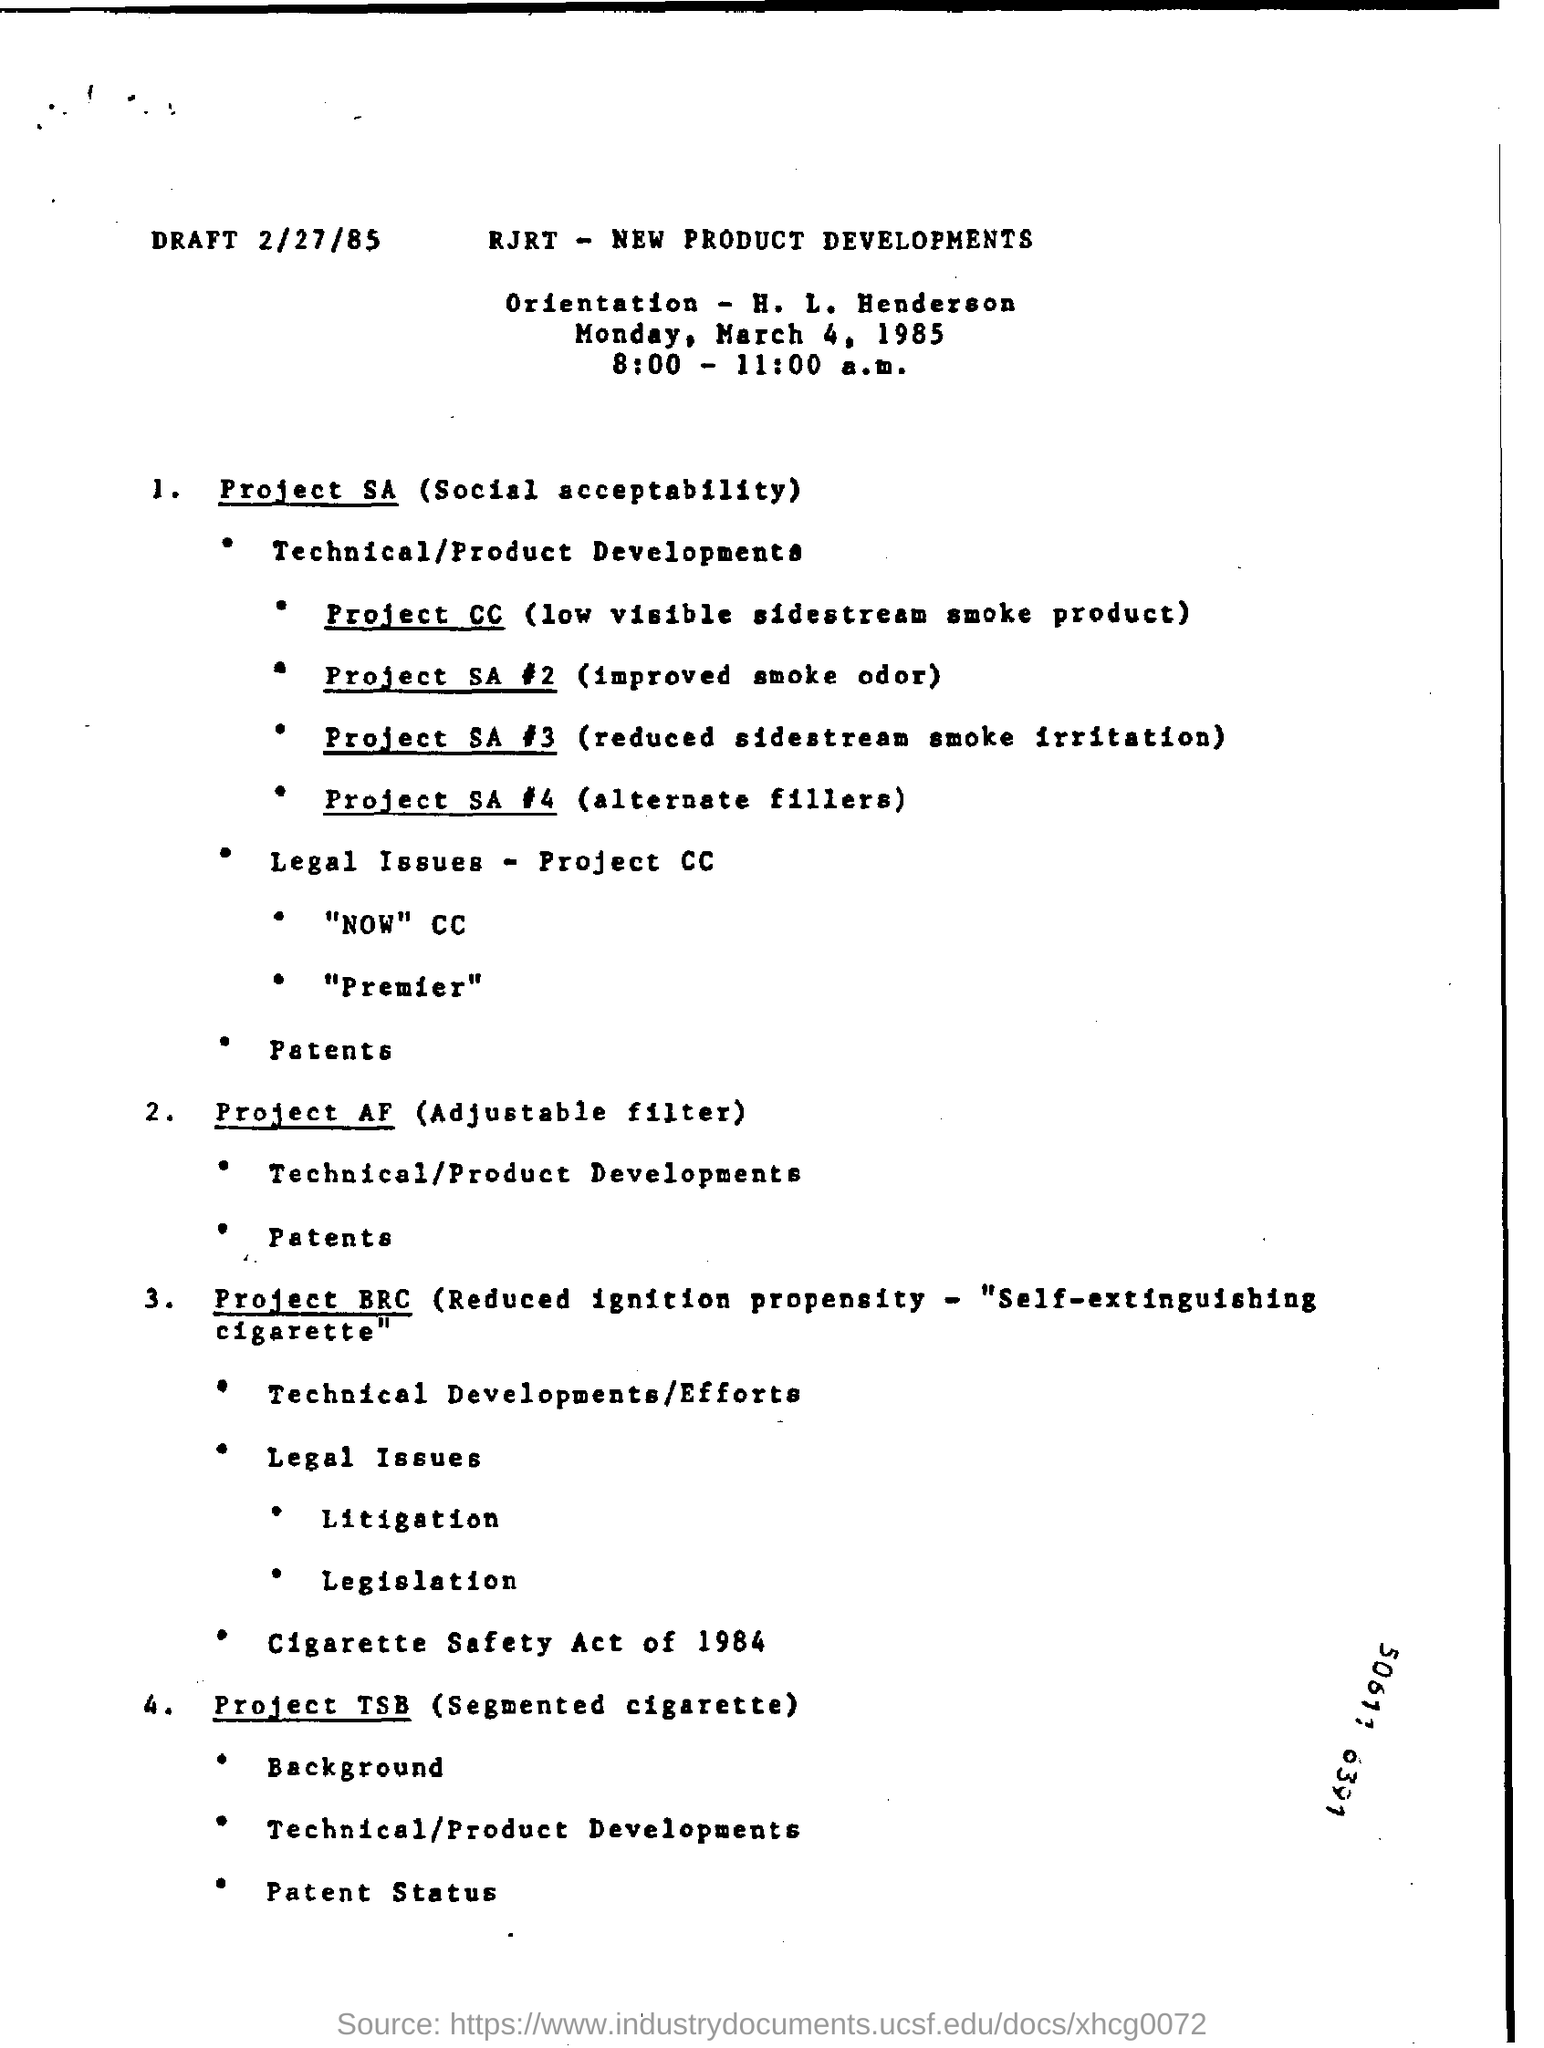Identify some key points in this picture. The draft date is February 27th, 1985. 